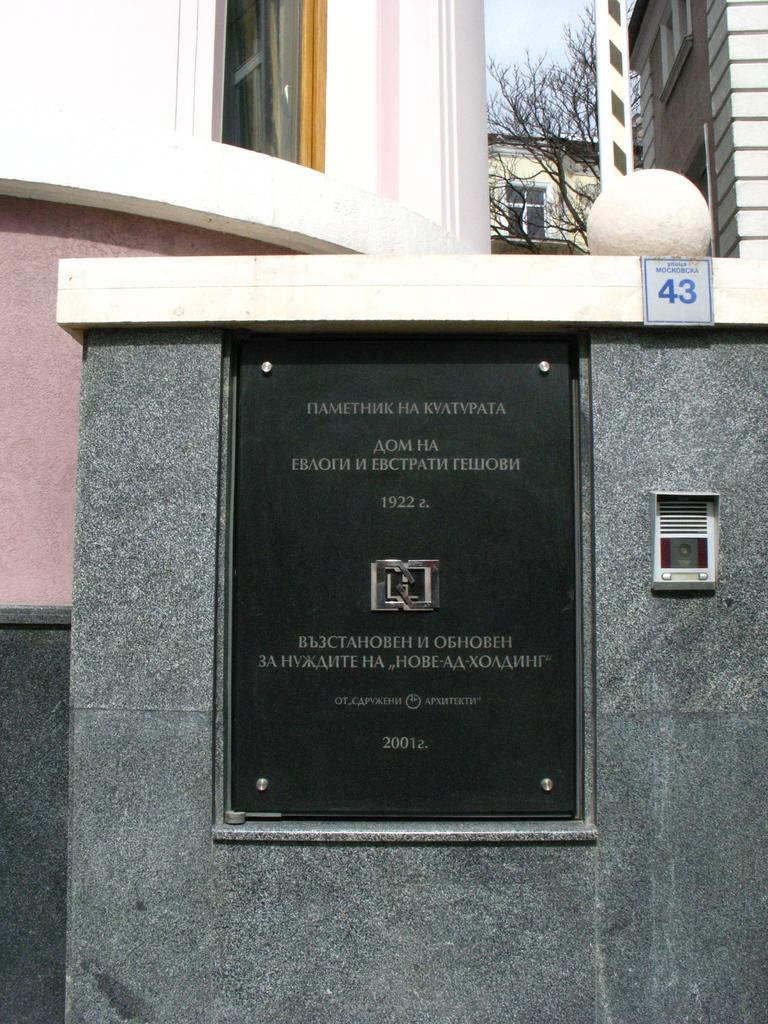What is on the wall in the image? There is a black color board on the wall. What can be seen in the background of the image? There are buildings, trees, and the sky visible in the background of the image. What type of brush is used to draw on the color board in the image? There is no brush or drawing visible on the color board in the image. What flavor of pie is being served in the image? There is no pie present in the image. 